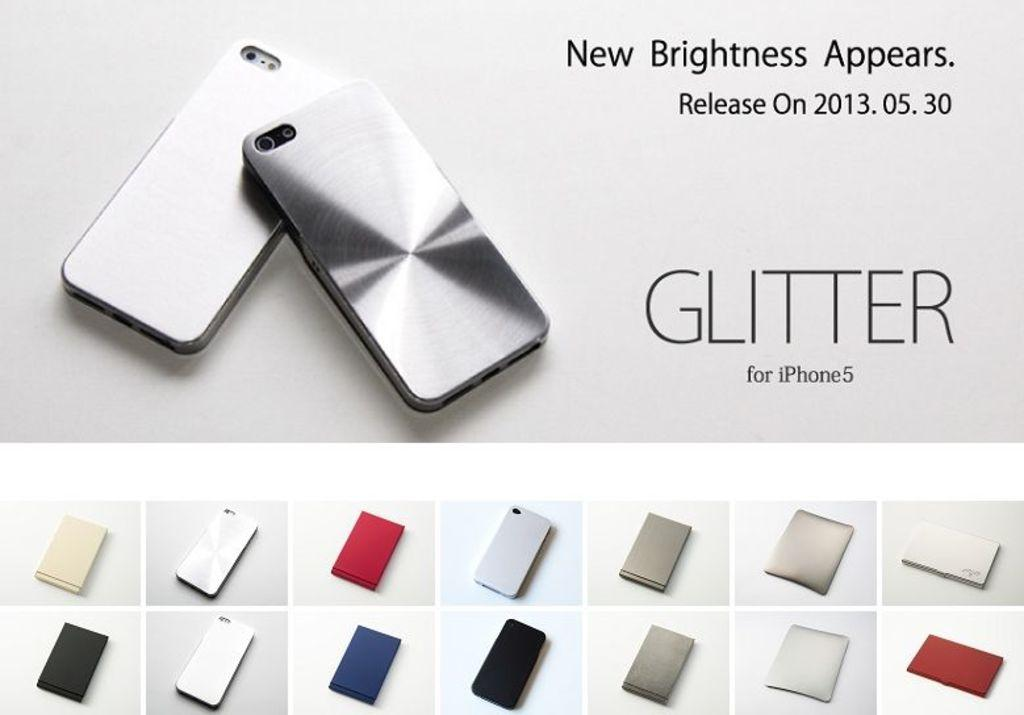Provide a one-sentence caption for the provided image. An advertisement for a Glitter case to be used on an iPhone 5. 